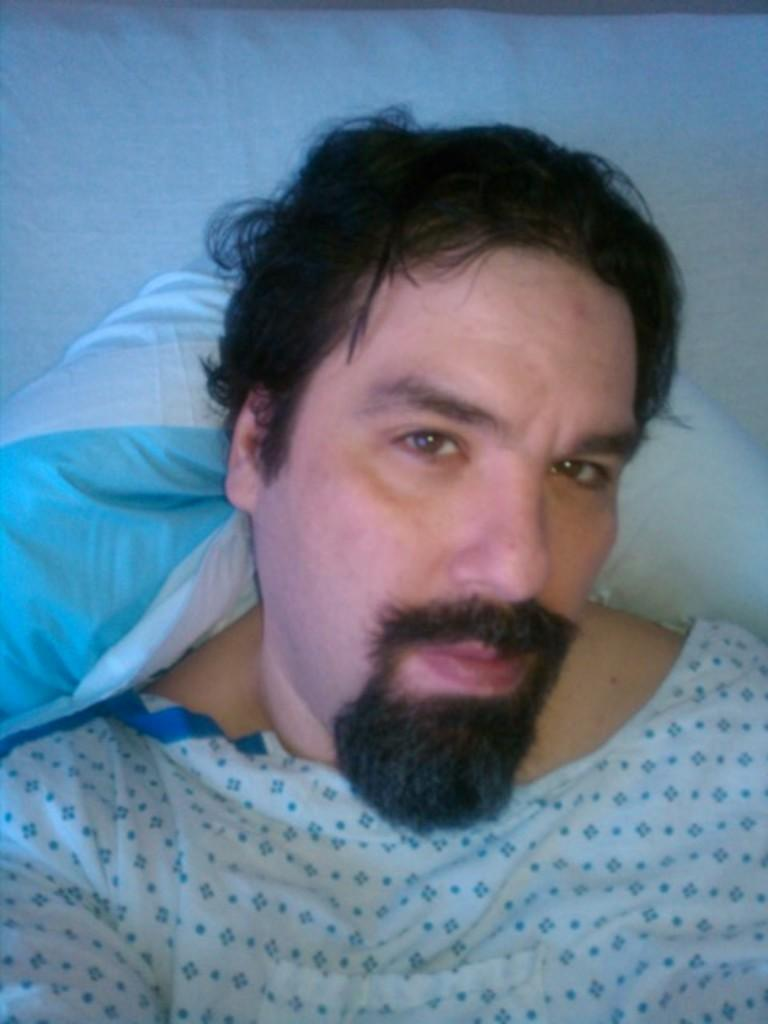Who or what is the main subject in the image? There is a person in the image. What is the person wearing? The person is wearing a white dress. What can be seen in the background of the image? The background of the image is white. How many grapes are visible in the image? There are no grapes present in the image. What type of muscle is being flexed by the person in the image? There is no indication of any muscles being flexed in the image, as the person is wearing a white dress and the focus is not on their body. 